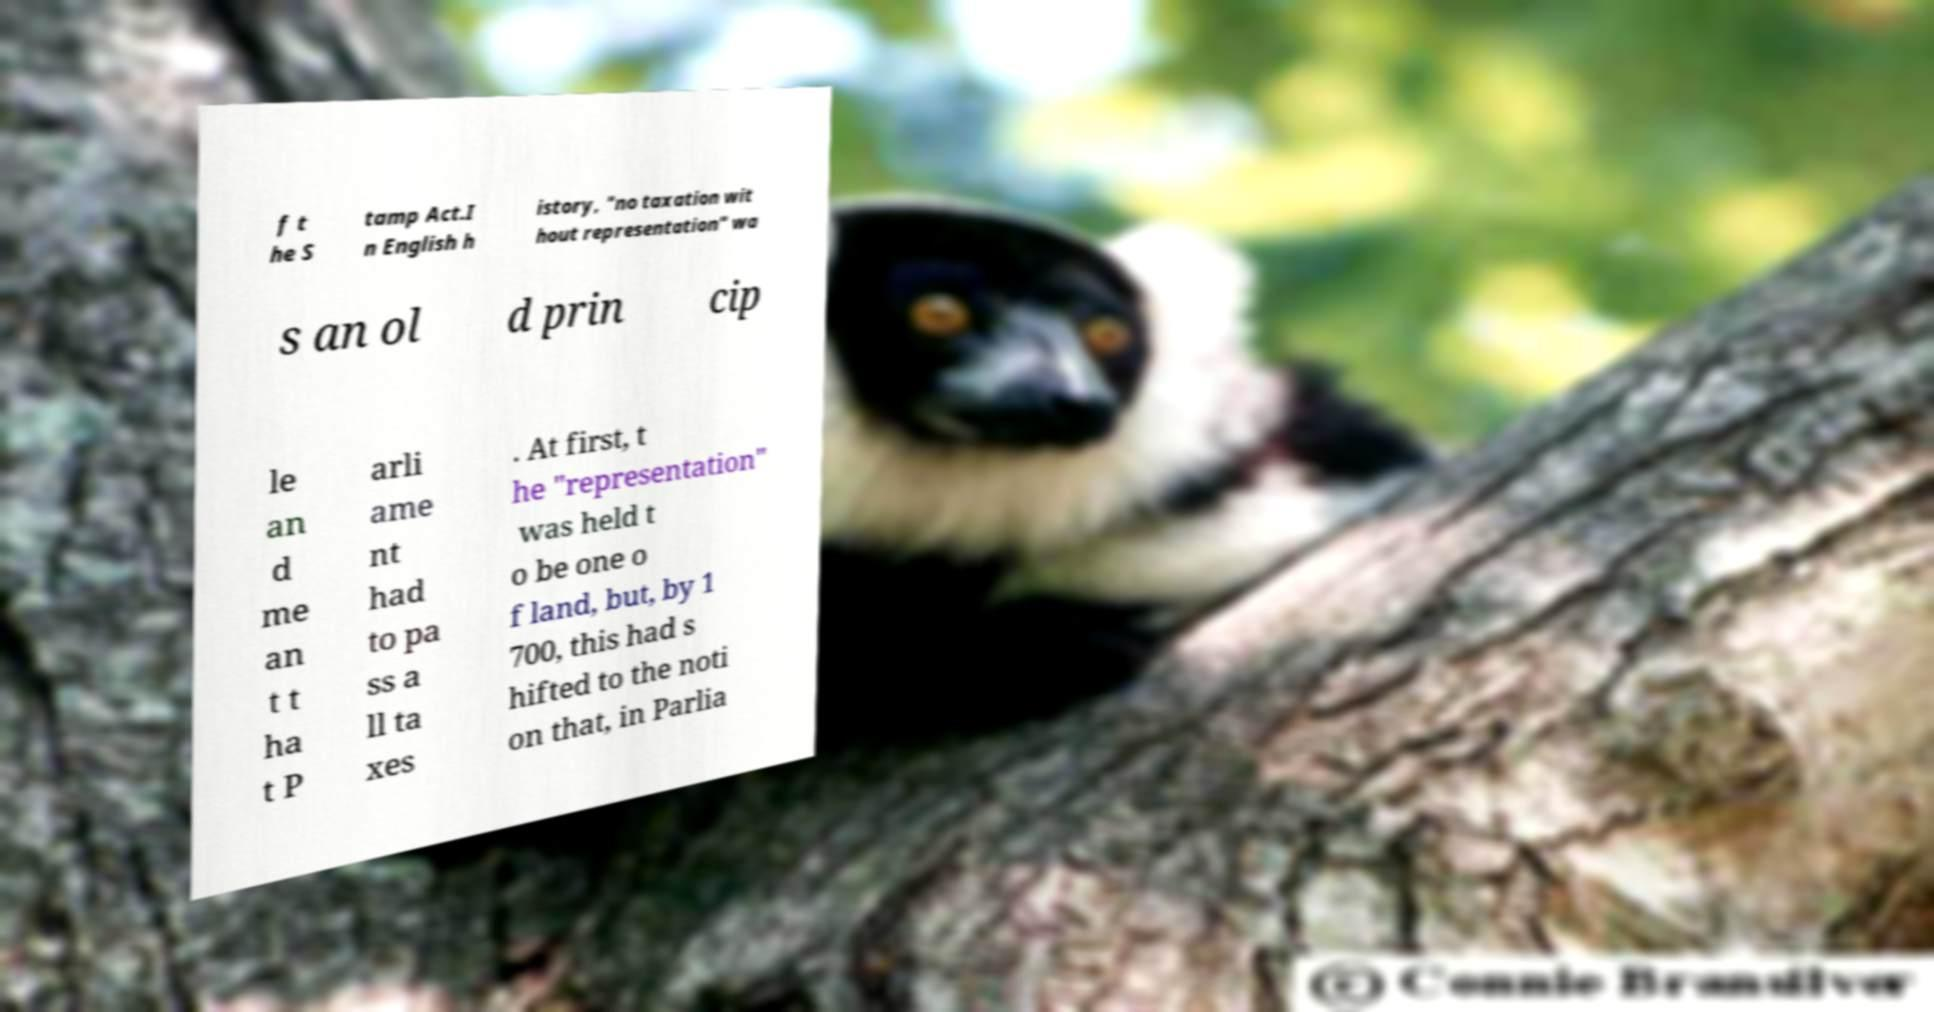Can you accurately transcribe the text from the provided image for me? f t he S tamp Act.I n English h istory, "no taxation wit hout representation" wa s an ol d prin cip le an d me an t t ha t P arli ame nt had to pa ss a ll ta xes . At first, t he "representation" was held t o be one o f land, but, by 1 700, this had s hifted to the noti on that, in Parlia 